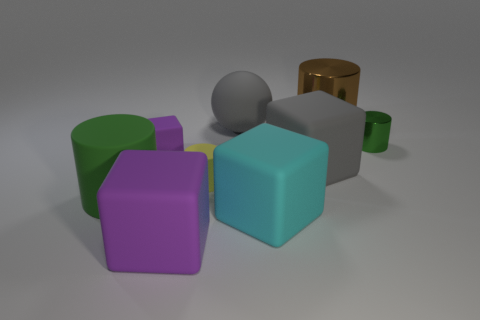Add 1 tiny green rubber balls. How many objects exist? 10 Subtract all cubes. How many objects are left? 5 Subtract all cyan cubes. Subtract all big gray rubber spheres. How many objects are left? 7 Add 7 small purple matte things. How many small purple matte things are left? 8 Add 7 large purple things. How many large purple things exist? 8 Subtract 1 yellow cylinders. How many objects are left? 8 